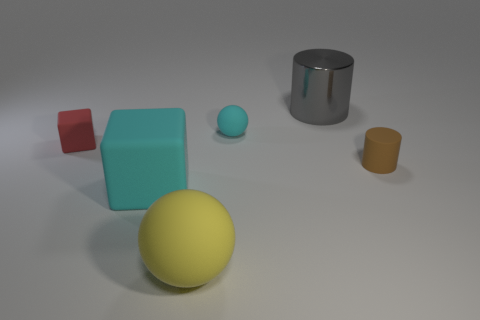Subtract all green balls. Subtract all red cylinders. How many balls are left? 2 Add 1 small red cylinders. How many objects exist? 7 Subtract all cylinders. How many objects are left? 4 Subtract 1 cyan cubes. How many objects are left? 5 Subtract all gray cylinders. Subtract all big yellow rubber things. How many objects are left? 4 Add 2 big metallic cylinders. How many big metallic cylinders are left? 3 Add 1 metallic things. How many metallic things exist? 2 